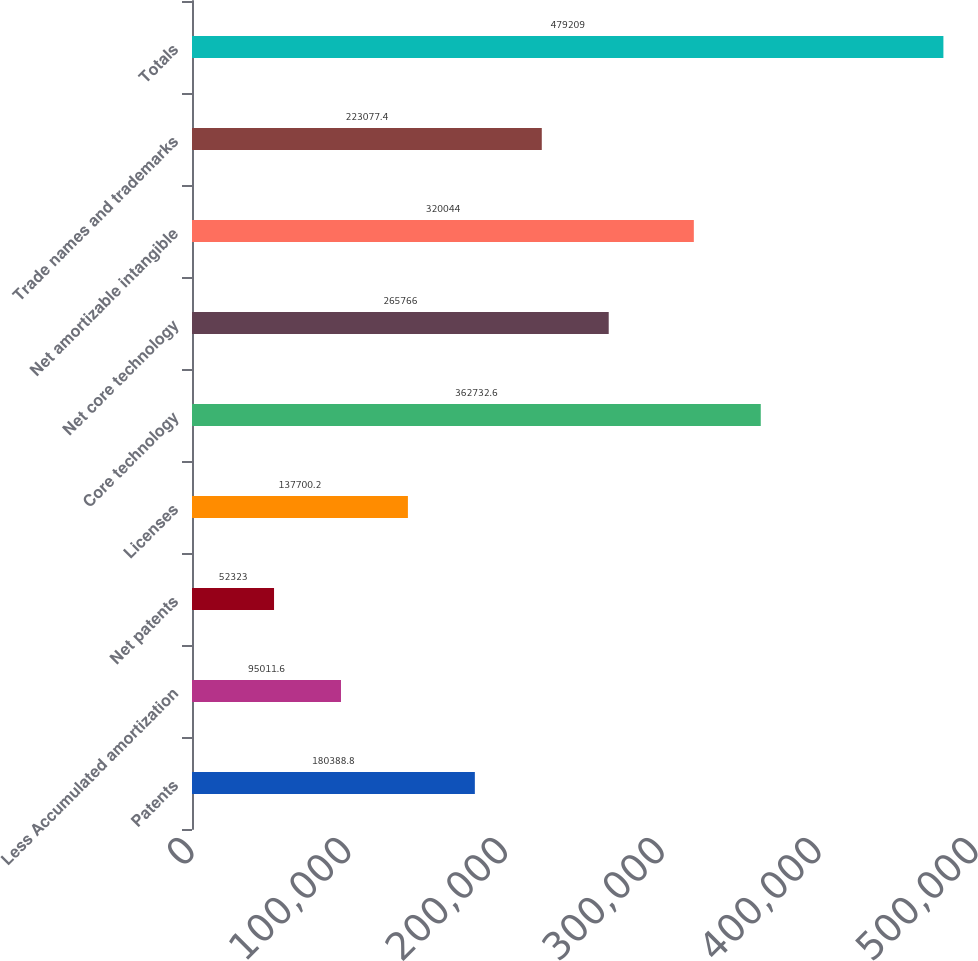Convert chart to OTSL. <chart><loc_0><loc_0><loc_500><loc_500><bar_chart><fcel>Patents<fcel>Less Accumulated amortization<fcel>Net patents<fcel>Licenses<fcel>Core technology<fcel>Net core technology<fcel>Net amortizable intangible<fcel>Trade names and trademarks<fcel>Totals<nl><fcel>180389<fcel>95011.6<fcel>52323<fcel>137700<fcel>362733<fcel>265766<fcel>320044<fcel>223077<fcel>479209<nl></chart> 